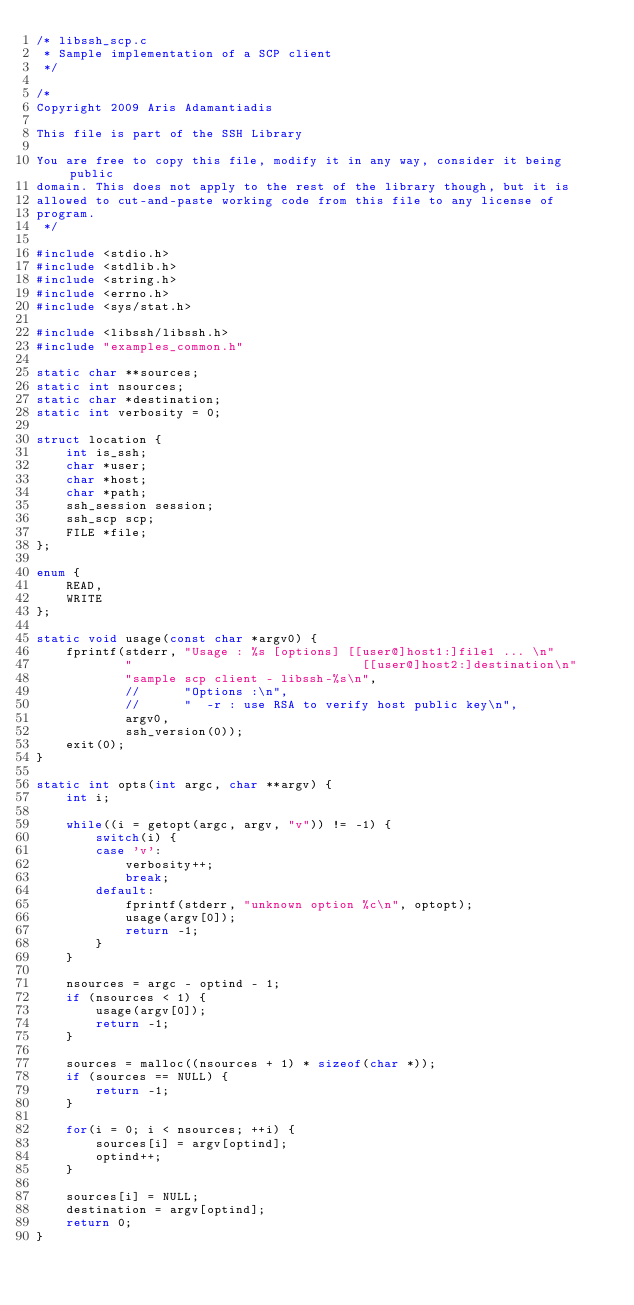<code> <loc_0><loc_0><loc_500><loc_500><_C_>/* libssh_scp.c
 * Sample implementation of a SCP client
 */

/*
Copyright 2009 Aris Adamantiadis

This file is part of the SSH Library

You are free to copy this file, modify it in any way, consider it being public
domain. This does not apply to the rest of the library though, but it is
allowed to cut-and-paste working code from this file to any license of
program.
 */

#include <stdio.h>
#include <stdlib.h>
#include <string.h>
#include <errno.h>
#include <sys/stat.h>

#include <libssh/libssh.h>
#include "examples_common.h"

static char **sources;
static int nsources;
static char *destination;
static int verbosity = 0;

struct location {
    int is_ssh;
    char *user;
    char *host;
    char *path;
    ssh_session session;
    ssh_scp scp;
    FILE *file;
};

enum {
    READ,
    WRITE
};

static void usage(const char *argv0) {
    fprintf(stderr, "Usage : %s [options] [[user@]host1:]file1 ... \n"
            "                               [[user@]host2:]destination\n"
            "sample scp client - libssh-%s\n",
            //      "Options :\n",
            //      "  -r : use RSA to verify host public key\n",
            argv0,
            ssh_version(0));
    exit(0);
}

static int opts(int argc, char **argv) {
    int i;

    while((i = getopt(argc, argv, "v")) != -1) {
        switch(i) {
        case 'v':
            verbosity++;
            break;
        default:
            fprintf(stderr, "unknown option %c\n", optopt);
            usage(argv[0]);
            return -1;
        }
    }

    nsources = argc - optind - 1;
    if (nsources < 1) {
        usage(argv[0]);
        return -1;
    }

    sources = malloc((nsources + 1) * sizeof(char *));
    if (sources == NULL) {
        return -1;
    }

    for(i = 0; i < nsources; ++i) {
        sources[i] = argv[optind];
        optind++;
    }

    sources[i] = NULL;
    destination = argv[optind];
    return 0;
}
</code> 